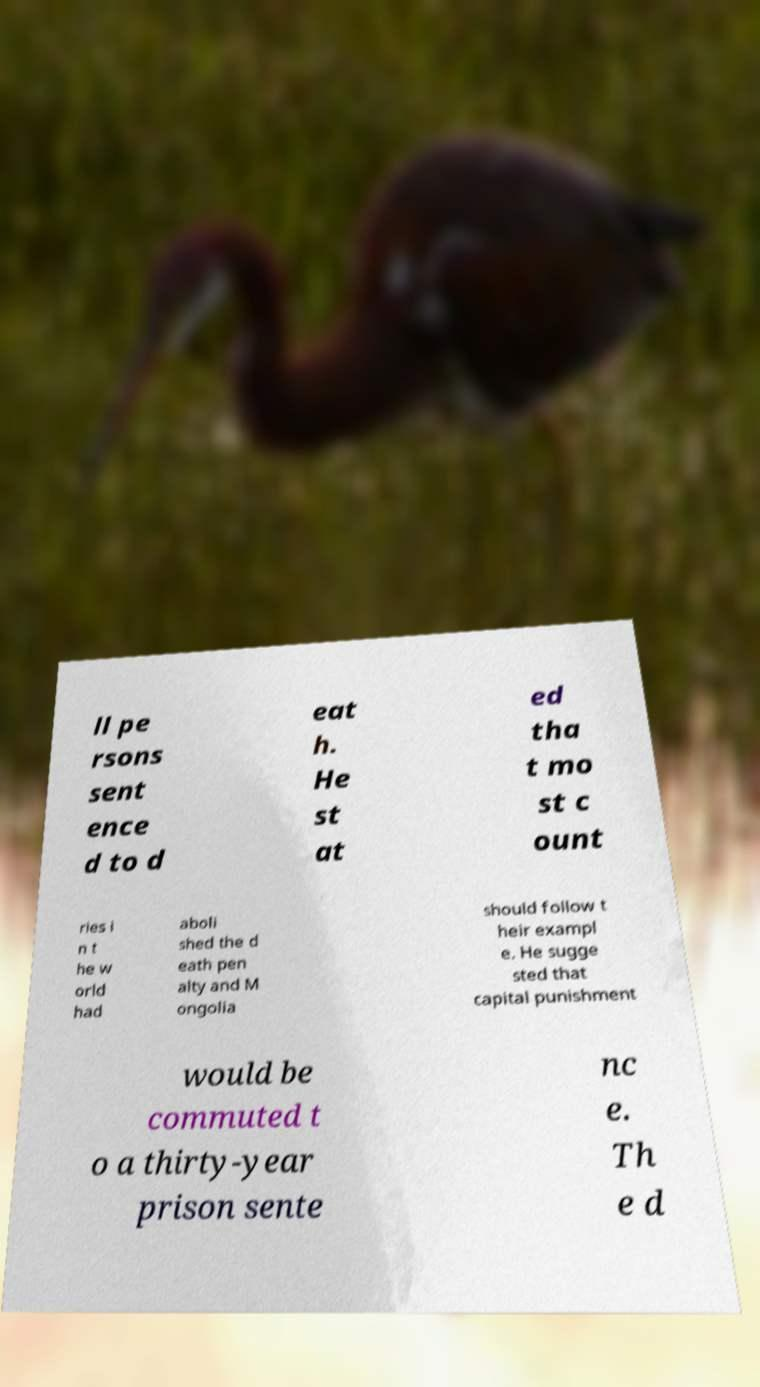What messages or text are displayed in this image? I need them in a readable, typed format. ll pe rsons sent ence d to d eat h. He st at ed tha t mo st c ount ries i n t he w orld had aboli shed the d eath pen alty and M ongolia should follow t heir exampl e. He sugge sted that capital punishment would be commuted t o a thirty-year prison sente nc e. Th e d 